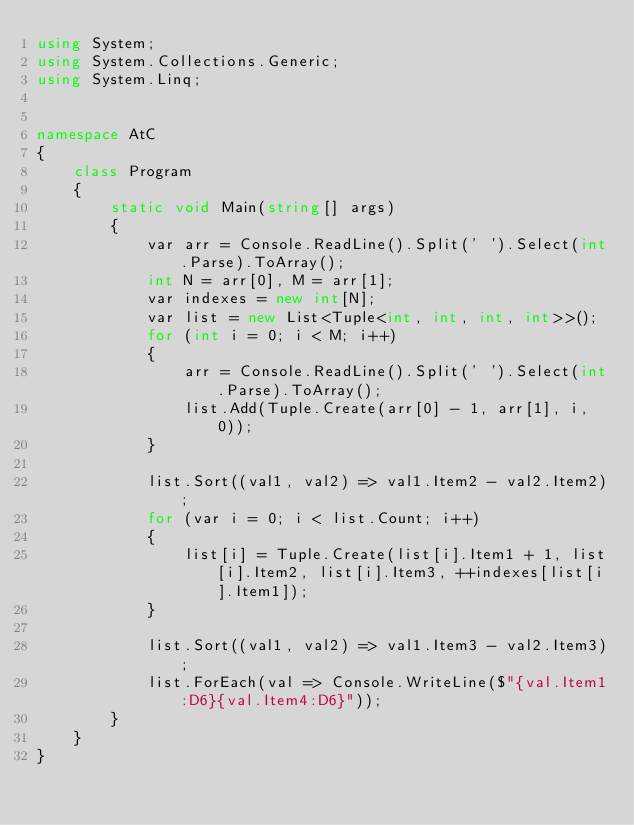Convert code to text. <code><loc_0><loc_0><loc_500><loc_500><_C#_>using System;
using System.Collections.Generic;
using System.Linq;


namespace AtC
{
    class Program
    {
        static void Main(string[] args)
        {
            var arr = Console.ReadLine().Split(' ').Select(int.Parse).ToArray();
            int N = arr[0], M = arr[1];
            var indexes = new int[N];
            var list = new List<Tuple<int, int, int, int>>();
            for (int i = 0; i < M; i++)
            {
                arr = Console.ReadLine().Split(' ').Select(int.Parse).ToArray();
                list.Add(Tuple.Create(arr[0] - 1, arr[1], i, 0));
            }

            list.Sort((val1, val2) => val1.Item2 - val2.Item2);
            for (var i = 0; i < list.Count; i++)
            {
                list[i] = Tuple.Create(list[i].Item1 + 1, list[i].Item2, list[i].Item3, ++indexes[list[i].Item1]);
            }

            list.Sort((val1, val2) => val1.Item3 - val2.Item3);
            list.ForEach(val => Console.WriteLine($"{val.Item1:D6}{val.Item4:D6}"));
        }
    }
}</code> 